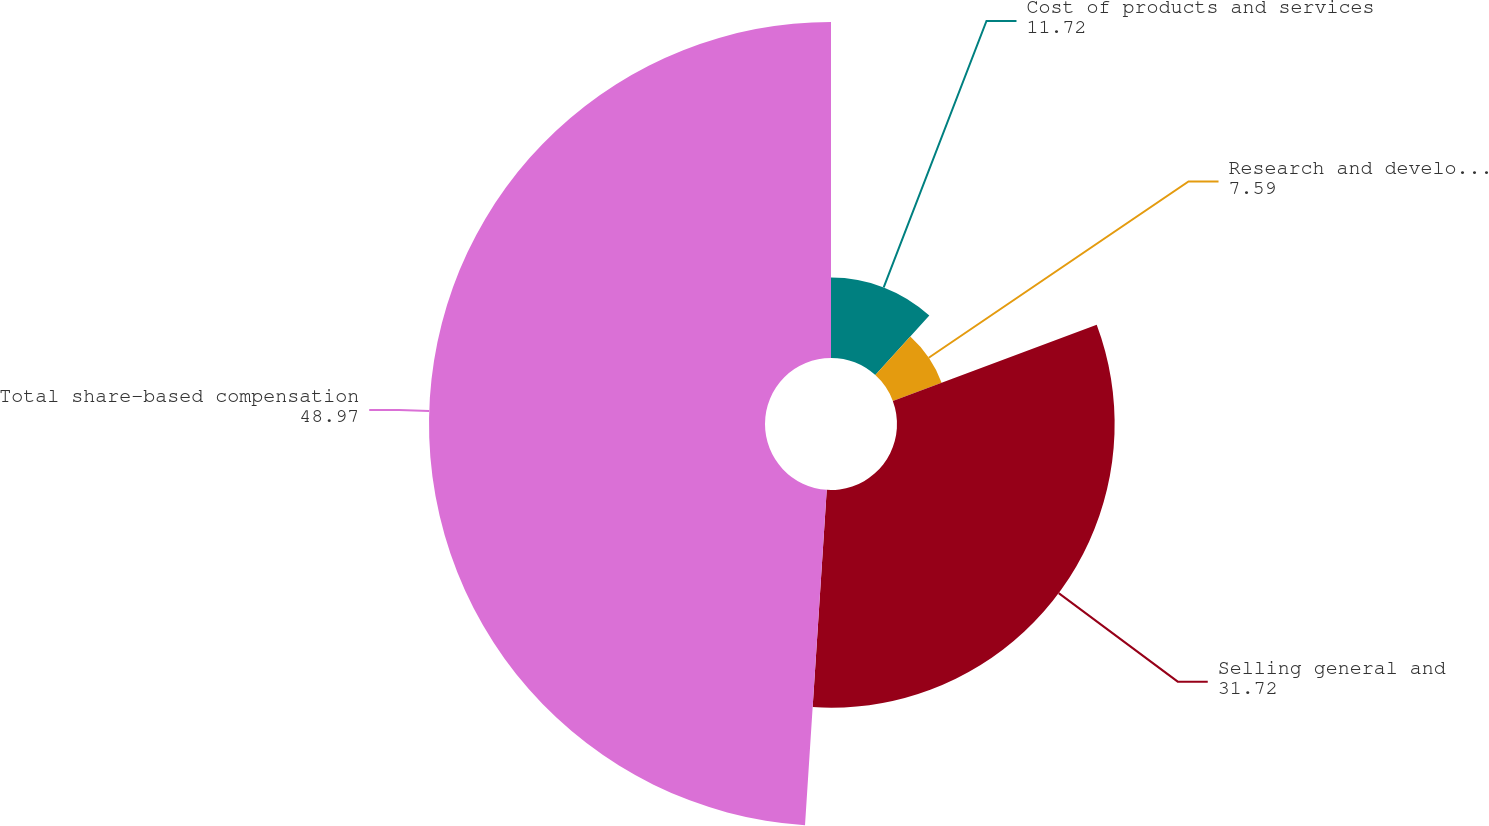Convert chart. <chart><loc_0><loc_0><loc_500><loc_500><pie_chart><fcel>Cost of products and services<fcel>Research and development<fcel>Selling general and<fcel>Total share-based compensation<nl><fcel>11.72%<fcel>7.59%<fcel>31.72%<fcel>48.97%<nl></chart> 